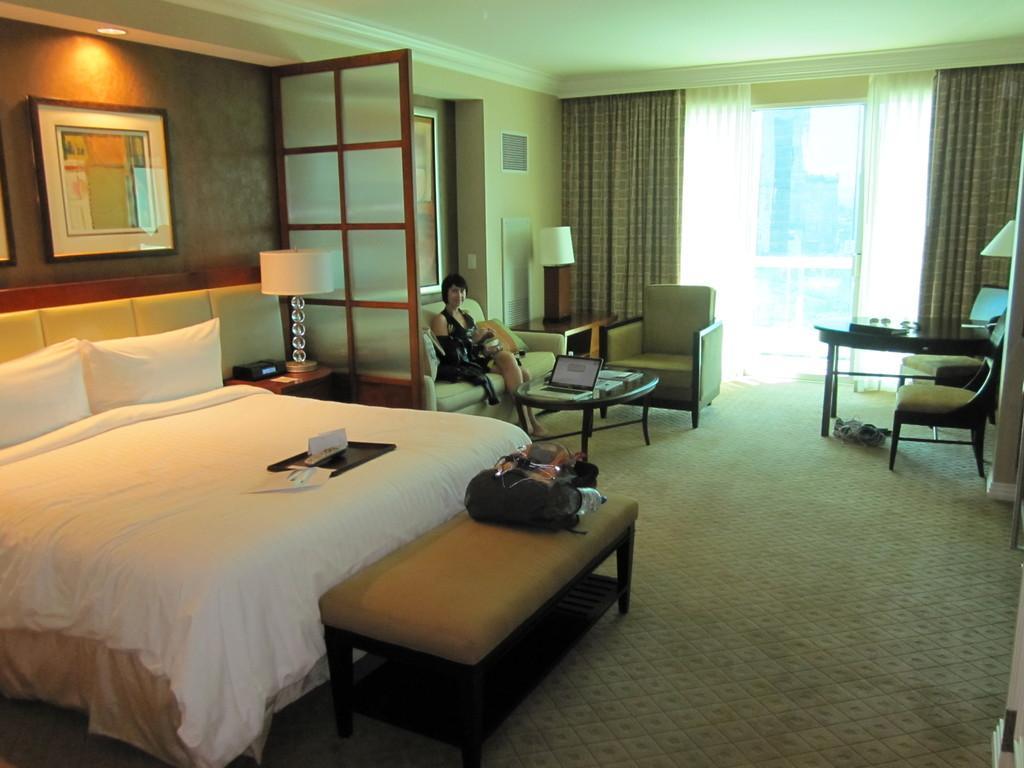Please provide a concise description of this image. In this image there is a person sitting on the couch and at the left side of the image there is a bed and at the right side of the image there is a chair and at the top left of the image there is a painting attached to the wall and at the backside of the image there is a window. 